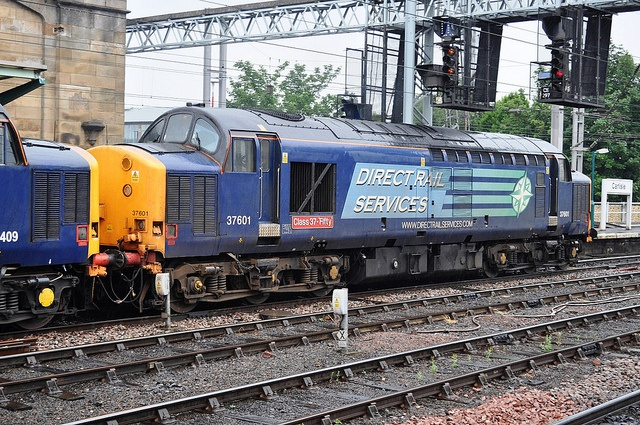Describe the objects in this image and their specific colors. I can see train in gray, black, and navy tones, traffic light in gray, black, and maroon tones, and traffic light in gray, black, and maroon tones in this image. 